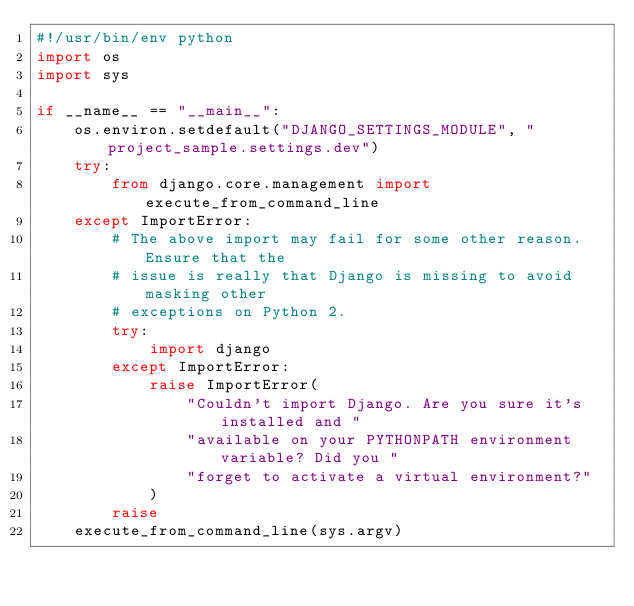Convert code to text. <code><loc_0><loc_0><loc_500><loc_500><_Python_>#!/usr/bin/env python
import os
import sys

if __name__ == "__main__":
    os.environ.setdefault("DJANGO_SETTINGS_MODULE", "project_sample.settings.dev")
    try:
        from django.core.management import execute_from_command_line
    except ImportError:
        # The above import may fail for some other reason. Ensure that the
        # issue is really that Django is missing to avoid masking other
        # exceptions on Python 2.
        try:
            import django
        except ImportError:
            raise ImportError(
                "Couldn't import Django. Are you sure it's installed and "
                "available on your PYTHONPATH environment variable? Did you "
                "forget to activate a virtual environment?"
            )
        raise
    execute_from_command_line(sys.argv)
</code> 